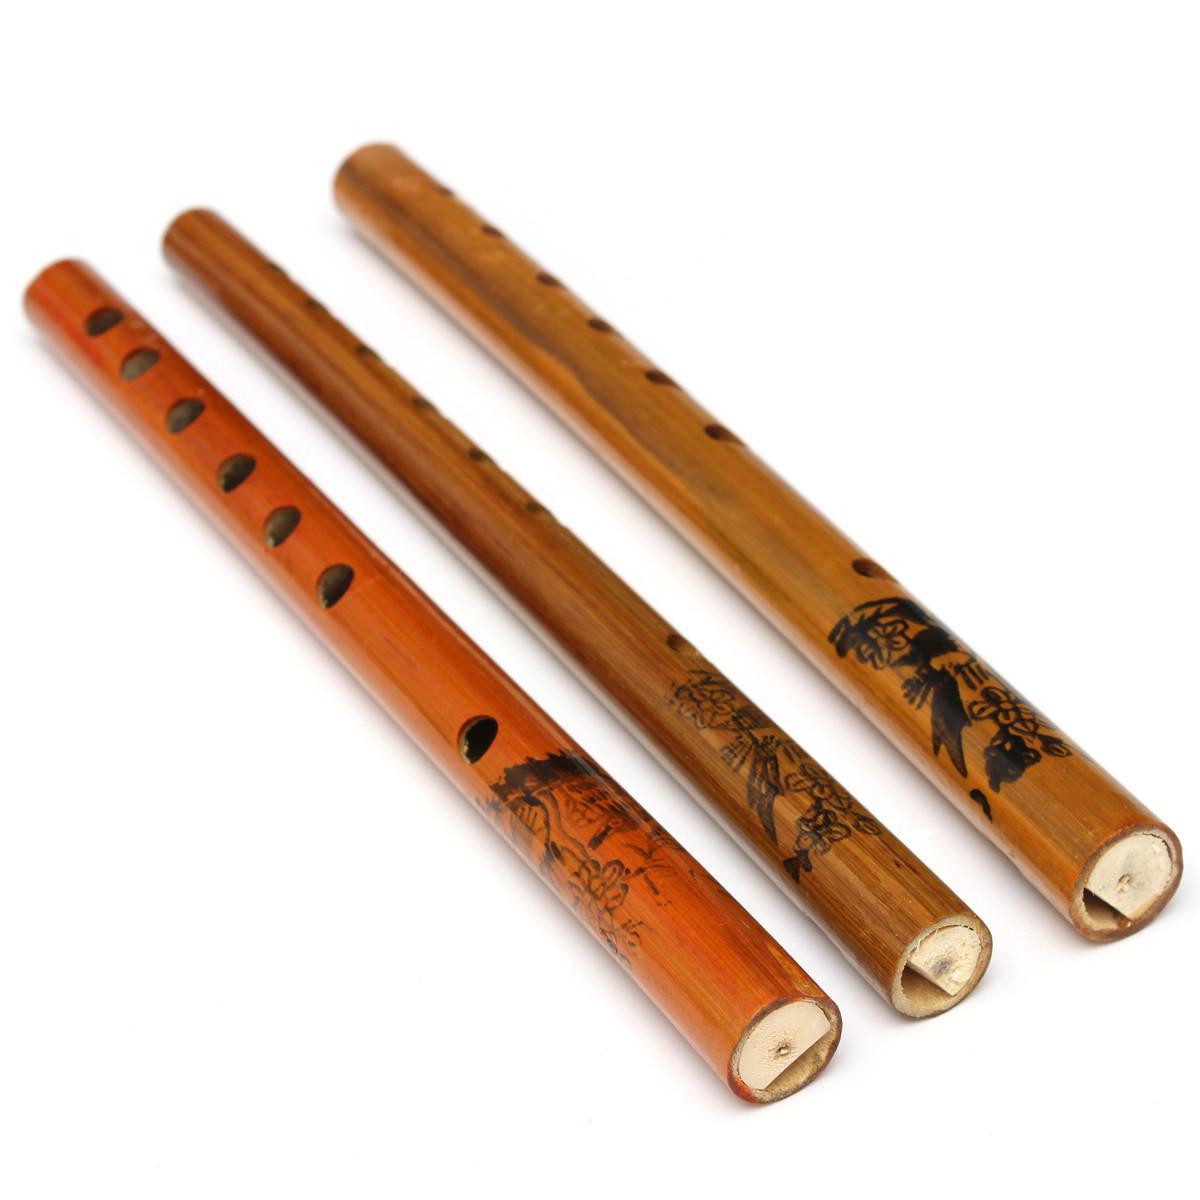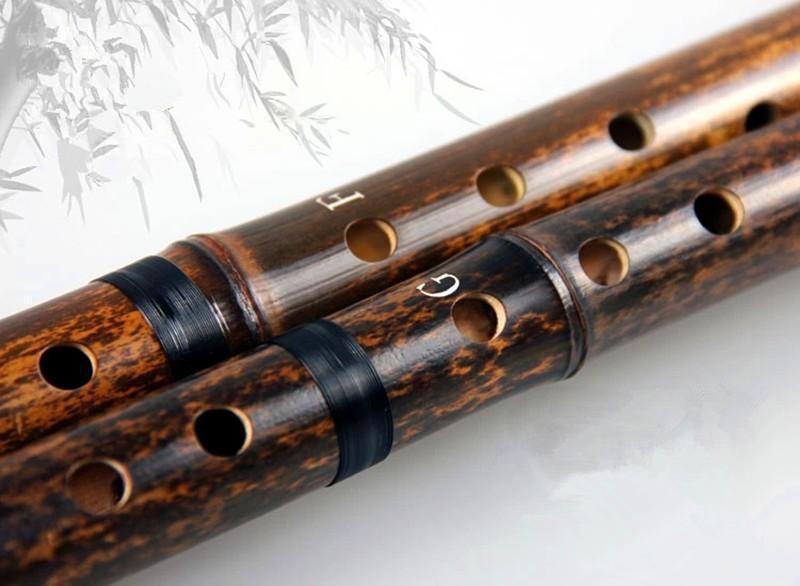The first image is the image on the left, the second image is the image on the right. For the images shown, is this caption "One image shows exactly three wooden flutes, and the other image contains at least one flute displayed diagonally." true? Answer yes or no. Yes. 